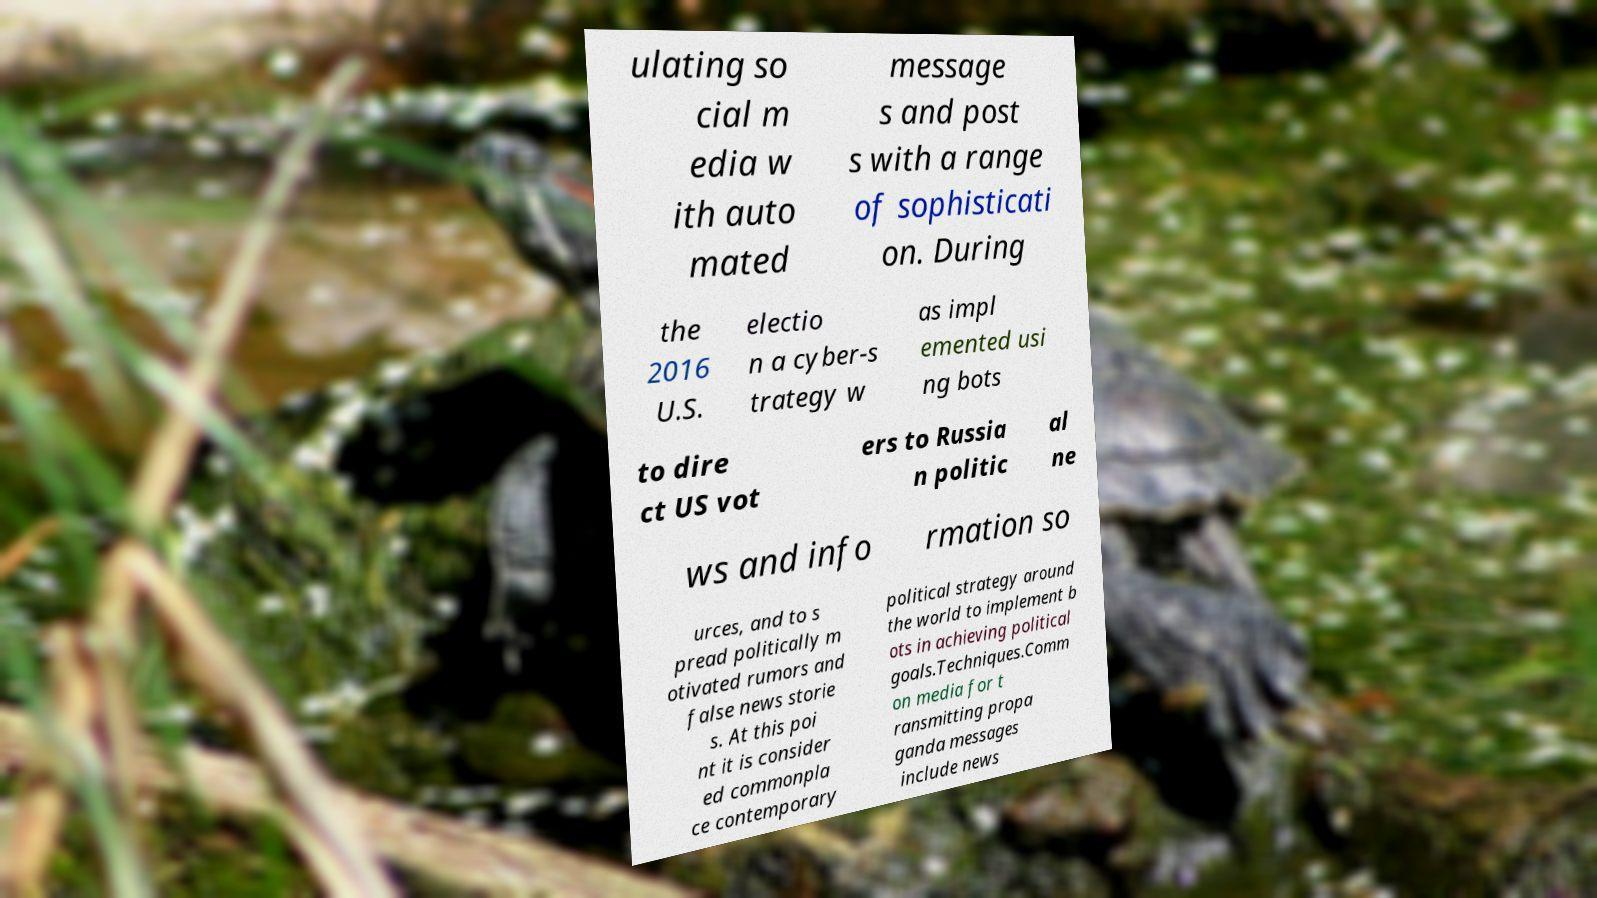Could you assist in decoding the text presented in this image and type it out clearly? ulating so cial m edia w ith auto mated message s and post s with a range of sophisticati on. During the 2016 U.S. electio n a cyber-s trategy w as impl emented usi ng bots to dire ct US vot ers to Russia n politic al ne ws and info rmation so urces, and to s pread politically m otivated rumors and false news storie s. At this poi nt it is consider ed commonpla ce contemporary political strategy around the world to implement b ots in achieving political goals.Techniques.Comm on media for t ransmitting propa ganda messages include news 